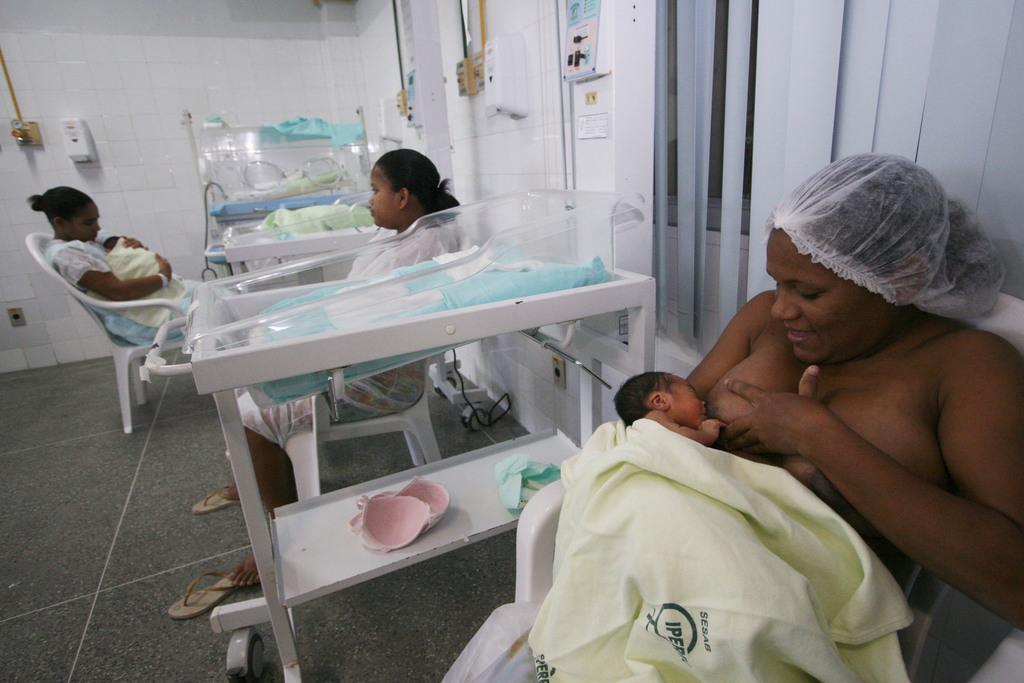Can you describe this image briefly? In this picture there are people, among them there are two women holding babies and we can see incubator beds, floor, chair, wall, window blind and objects. 